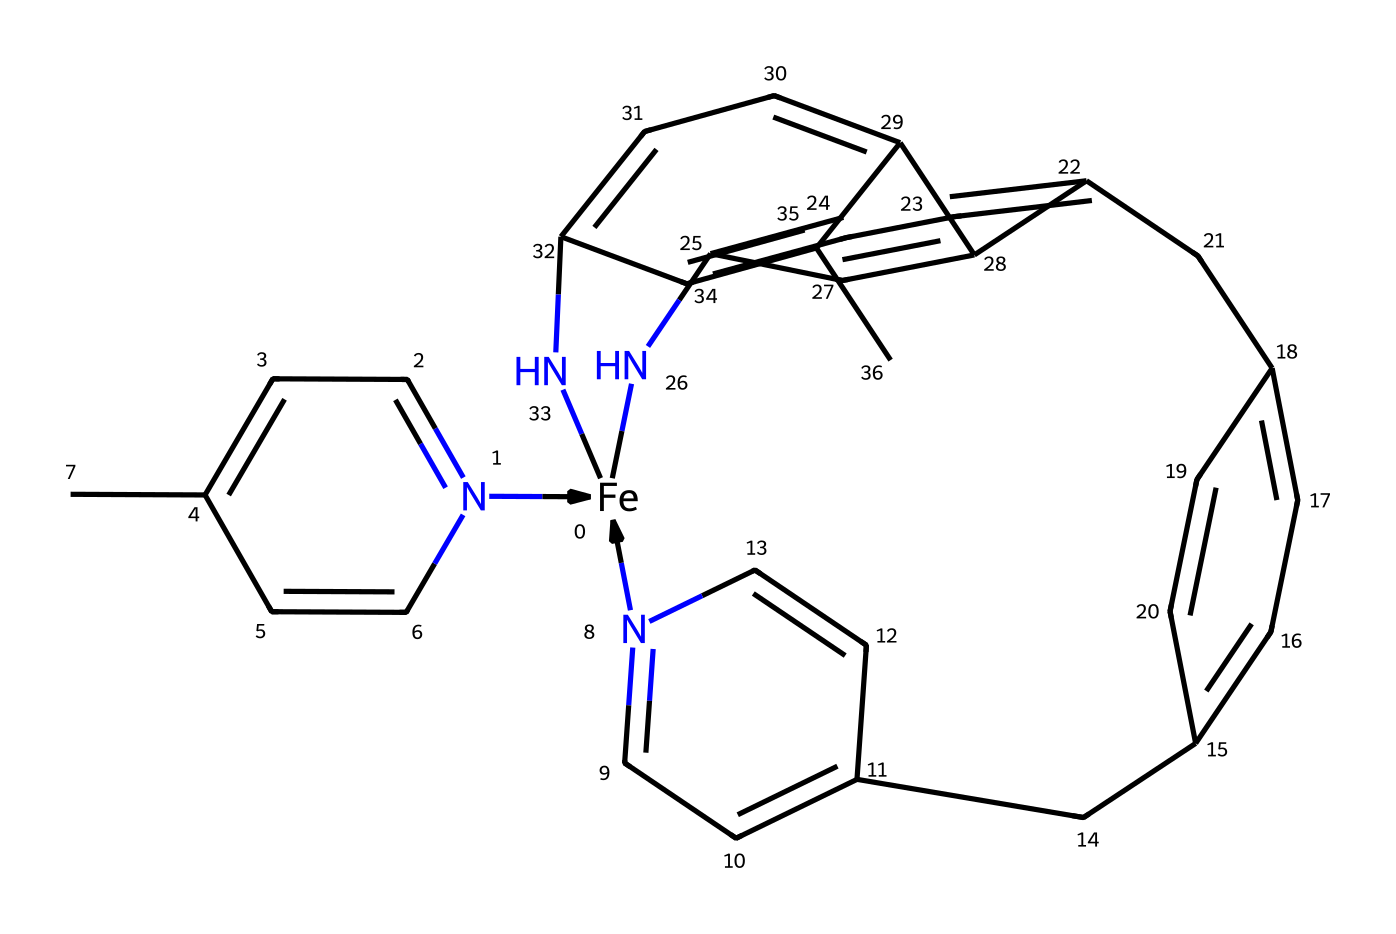How many nitrogen atoms are present in this compound? The SMILES representation shows five instances of the letter 'N', indicating there are five nitrogen atoms in the chemical structure.
Answer: five What is the central metal atom in this structure? The SMILES notation begins with “[Fe]”, which signifies that iron is present as the central metal atom in this organometallic compound.
Answer: iron How many cyclic structures are found in this chemical? By analyzing the SMILES, we see that there are multiple numbers corresponding to cycles, where the number four cycles are denoted. Altogether, the chemical includes four distinct rings.
Answer: four Which functional groups can be identified in the structure? Observing the SMILES, there are cyclic aromatic components and nitrogen substitution, but primarily, its structure comprises of multiple aromatic rings which serve as functional groups.
Answer: aromatic rings Which part holds the organometallic characteristic? The presence of the iron atom attached to carbon-containing groups indicates the organometallic nature. The structure has iron directly bonded to carbon atoms, defining its organometallic character.
Answer: iron to carbon linkage What is the significance of the nitrogen atoms in this compound? The nitrogen atoms are likely involved in chelation with the central iron, contributing to the overall stability and biological function of artificial blood substitutes, as metal complexes often require ligands.
Answer: stability and function 